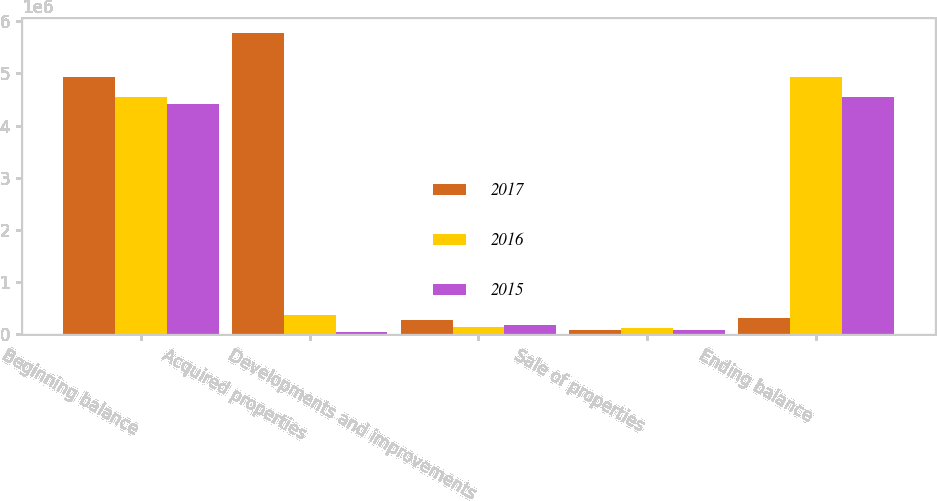<chart> <loc_0><loc_0><loc_500><loc_500><stacked_bar_chart><ecel><fcel>Beginning balance<fcel>Acquired properties<fcel>Developments and improvements<fcel>Sale of properties<fcel>Ending balance<nl><fcel>2017<fcel>4.9335e+06<fcel>5.77226e+06<fcel>273871<fcel>86814<fcel>321940<nl><fcel>2016<fcel>4.5459e+06<fcel>370010<fcel>148904<fcel>126855<fcel>4.9335e+06<nl><fcel>2015<fcel>4.40989e+06<fcel>39850<fcel>174972<fcel>78808<fcel>4.5459e+06<nl></chart> 